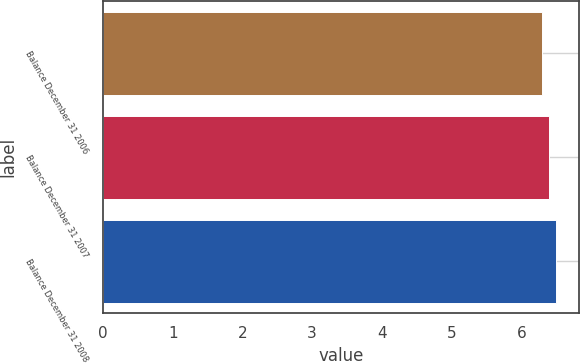Convert chart to OTSL. <chart><loc_0><loc_0><loc_500><loc_500><bar_chart><fcel>Balance December 31 2006<fcel>Balance December 31 2007<fcel>Balance December 31 2008<nl><fcel>6.3<fcel>6.4<fcel>6.5<nl></chart> 